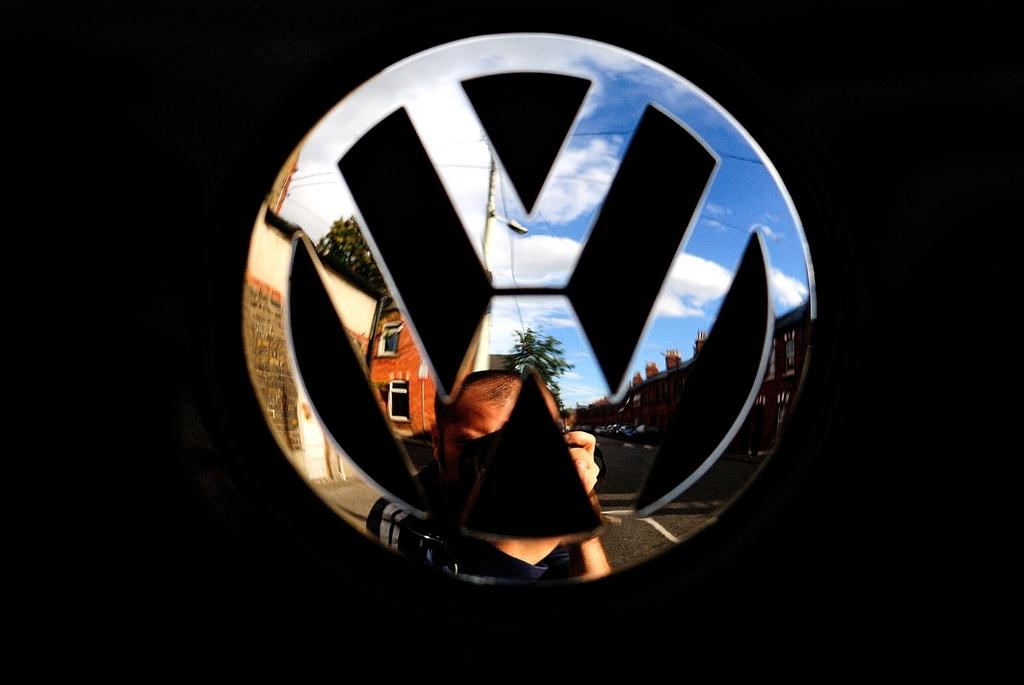What is the color of the surface in the image? The surface in the image is black. What is on the black surface? There is a car logo on the black surface. What can be seen in the reflection of the car logo? The reflection includes buildings, trees, a road, and a man. What type of flowers are blooming in the rainstorm in the image? There is no rainstorm or flowers present in the image; it features a black surface with a car logo and its reflection. 